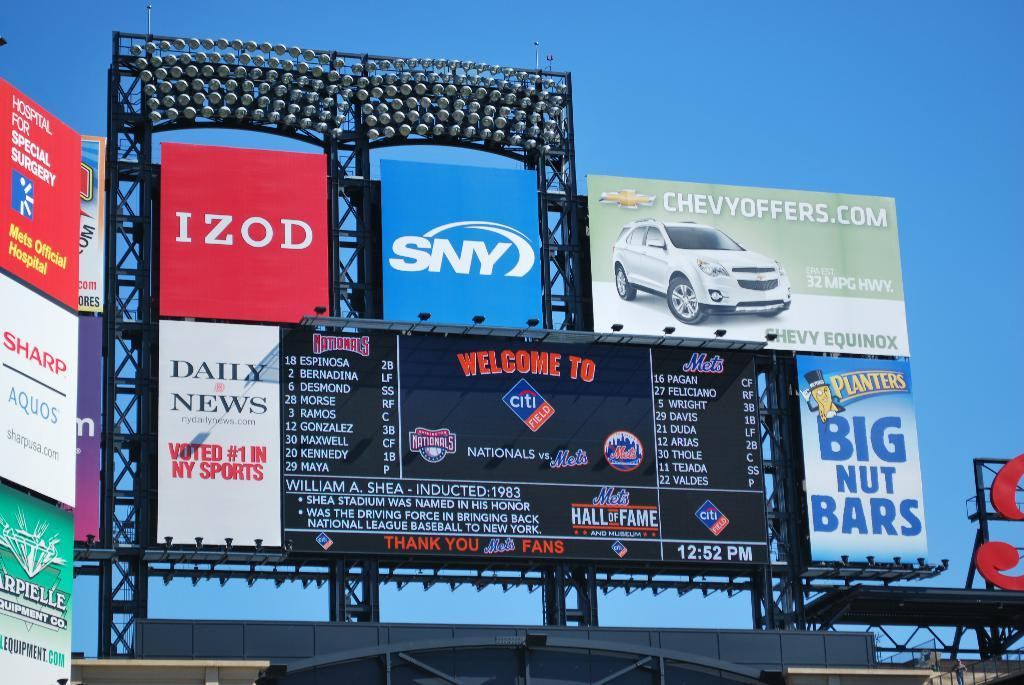<image>
Give a short and clear explanation of the subsequent image. A group of commercial signs such as Izod SyN and several other companies together. 